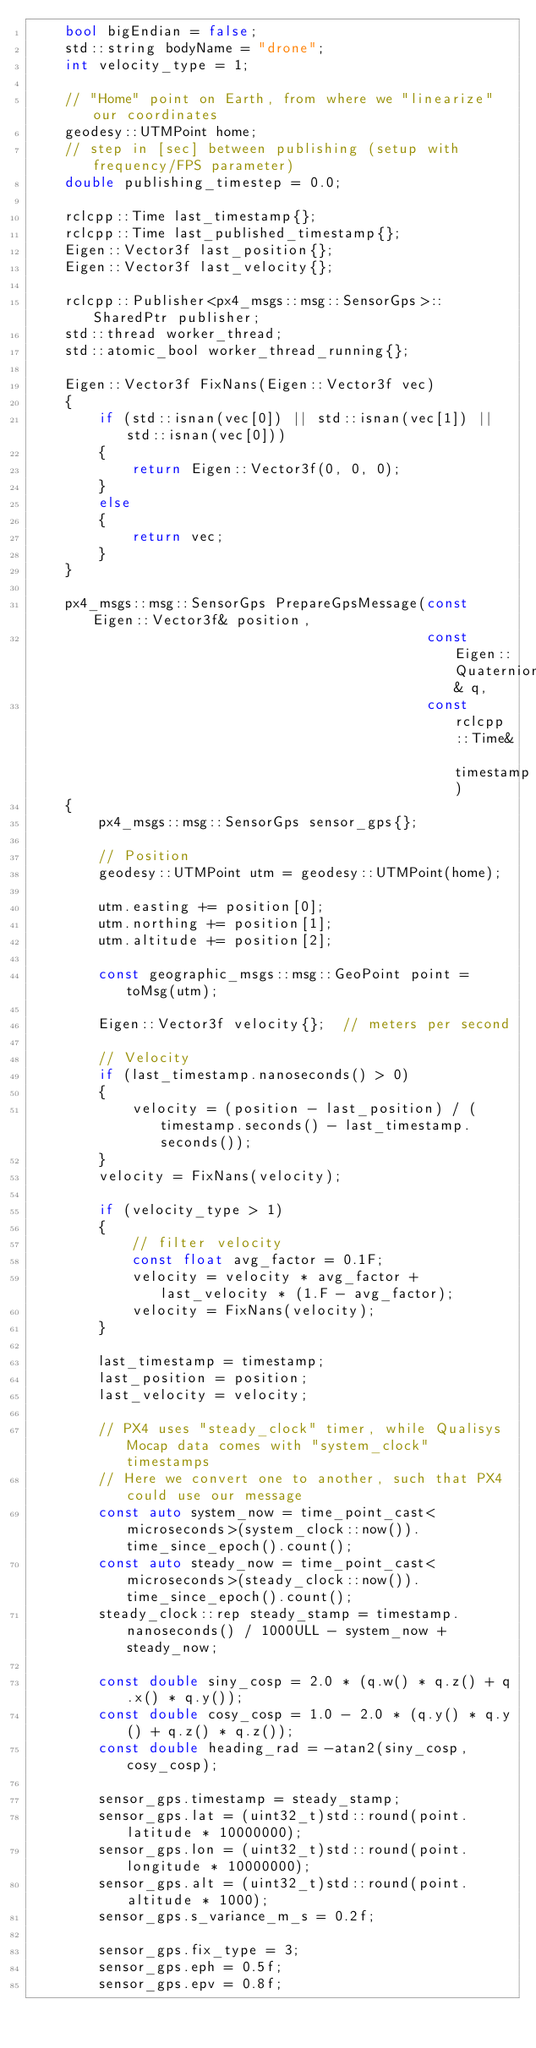Convert code to text. <code><loc_0><loc_0><loc_500><loc_500><_C++_>    bool bigEndian = false;
    std::string bodyName = "drone";
    int velocity_type = 1;

    // "Home" point on Earth, from where we "linearize" our coordinates
    geodesy::UTMPoint home;
    // step in [sec] between publishing (setup with frequency/FPS parameter)
    double publishing_timestep = 0.0;

    rclcpp::Time last_timestamp{};
    rclcpp::Time last_published_timestamp{};
    Eigen::Vector3f last_position{};
    Eigen::Vector3f last_velocity{};

    rclcpp::Publisher<px4_msgs::msg::SensorGps>::SharedPtr publisher;
    std::thread worker_thread;
    std::atomic_bool worker_thread_running{};

    Eigen::Vector3f FixNans(Eigen::Vector3f vec)
    {
        if (std::isnan(vec[0]) || std::isnan(vec[1]) || std::isnan(vec[0]))
        {
            return Eigen::Vector3f(0, 0, 0);
        }
        else
        {
            return vec;
        }
    }

    px4_msgs::msg::SensorGps PrepareGpsMessage(const Eigen::Vector3f& position,
                                               const Eigen::Quaternionf& q,
                                               const rclcpp::Time& timestamp)
    {
        px4_msgs::msg::SensorGps sensor_gps{};

        // Position
        geodesy::UTMPoint utm = geodesy::UTMPoint(home);

        utm.easting += position[0];
        utm.northing += position[1];
        utm.altitude += position[2];

        const geographic_msgs::msg::GeoPoint point = toMsg(utm);

        Eigen::Vector3f velocity{};  // meters per second

        // Velocity
        if (last_timestamp.nanoseconds() > 0)
        {
            velocity = (position - last_position) / (timestamp.seconds() - last_timestamp.seconds());
        }
        velocity = FixNans(velocity);

        if (velocity_type > 1)
        {
            // filter velocity
            const float avg_factor = 0.1F;
            velocity = velocity * avg_factor + last_velocity * (1.F - avg_factor);
            velocity = FixNans(velocity);
        }

        last_timestamp = timestamp;
        last_position = position;
        last_velocity = velocity;

        // PX4 uses "steady_clock" timer, while Qualisys Mocap data comes with "system_clock" timestamps
        // Here we convert one to another, such that PX4 could use our message
        const auto system_now = time_point_cast<microseconds>(system_clock::now()).time_since_epoch().count();
        const auto steady_now = time_point_cast<microseconds>(steady_clock::now()).time_since_epoch().count();
        steady_clock::rep steady_stamp = timestamp.nanoseconds() / 1000ULL - system_now + steady_now;

        const double siny_cosp = 2.0 * (q.w() * q.z() + q.x() * q.y());
        const double cosy_cosp = 1.0 - 2.0 * (q.y() * q.y() + q.z() * q.z());
        const double heading_rad = -atan2(siny_cosp, cosy_cosp);

        sensor_gps.timestamp = steady_stamp;
        sensor_gps.lat = (uint32_t)std::round(point.latitude * 10000000);
        sensor_gps.lon = (uint32_t)std::round(point.longitude * 10000000);
        sensor_gps.alt = (uint32_t)std::round(point.altitude * 1000);
        sensor_gps.s_variance_m_s = 0.2f;

        sensor_gps.fix_type = 3;
        sensor_gps.eph = 0.5f;
        sensor_gps.epv = 0.8f;</code> 